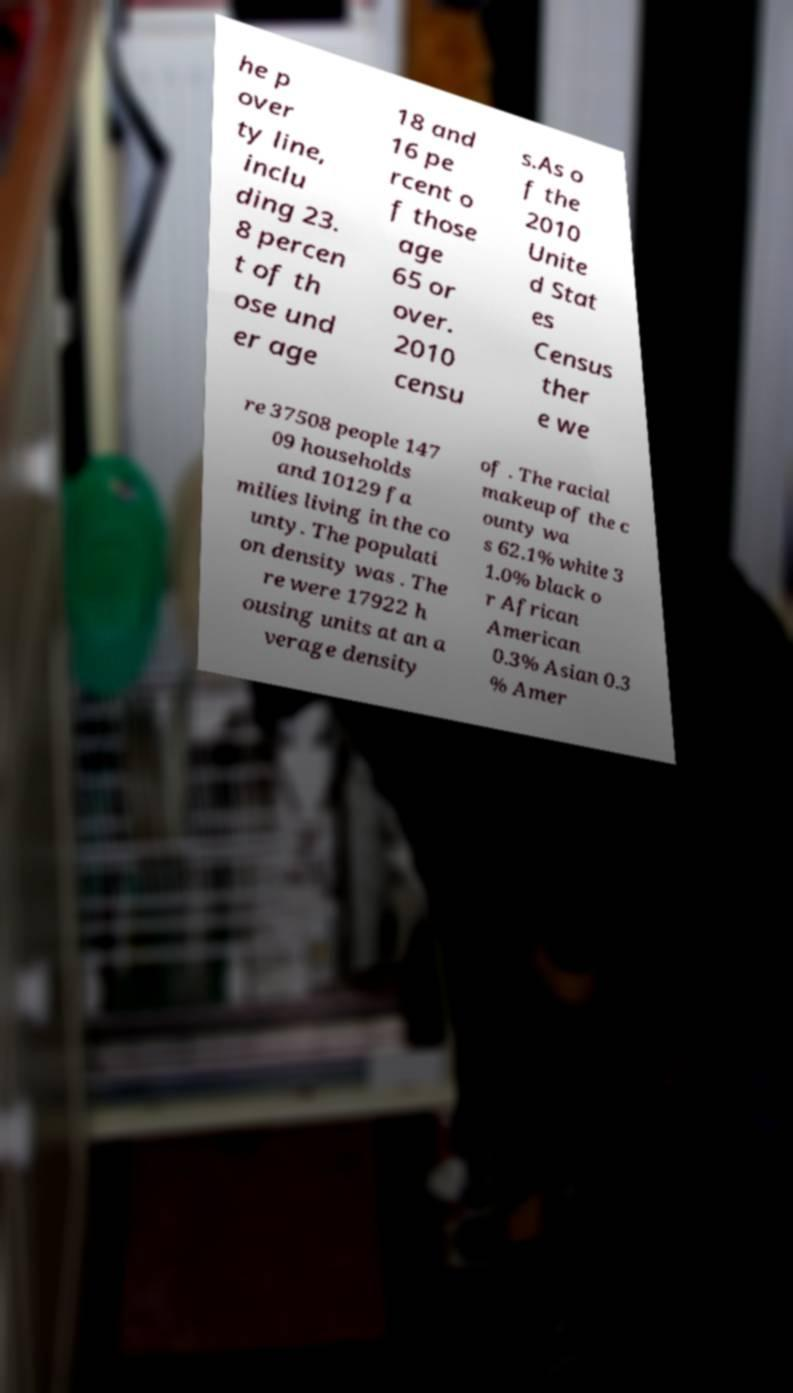Can you accurately transcribe the text from the provided image for me? he p over ty line, inclu ding 23. 8 percen t of th ose und er age 18 and 16 pe rcent o f those age 65 or over. 2010 censu s.As o f the 2010 Unite d Stat es Census ther e we re 37508 people 147 09 households and 10129 fa milies living in the co unty. The populati on density was . The re were 17922 h ousing units at an a verage density of . The racial makeup of the c ounty wa s 62.1% white 3 1.0% black o r African American 0.3% Asian 0.3 % Amer 